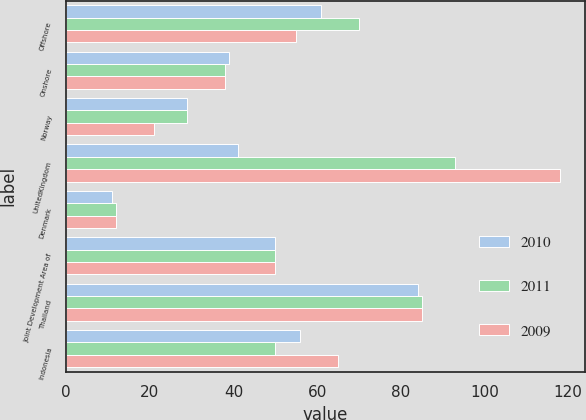<chart> <loc_0><loc_0><loc_500><loc_500><stacked_bar_chart><ecel><fcel>Offshore<fcel>Onshore<fcel>Norway<fcel>UnitedKingdom<fcel>Denmark<fcel>Joint Development Area of<fcel>Thailand<fcel>Indonesia<nl><fcel>2010<fcel>61<fcel>39<fcel>29<fcel>41<fcel>11<fcel>50<fcel>84<fcel>56<nl><fcel>2011<fcel>70<fcel>38<fcel>29<fcel>93<fcel>12<fcel>50<fcel>85<fcel>50<nl><fcel>2009<fcel>55<fcel>38<fcel>21<fcel>118<fcel>12<fcel>50<fcel>85<fcel>65<nl></chart> 